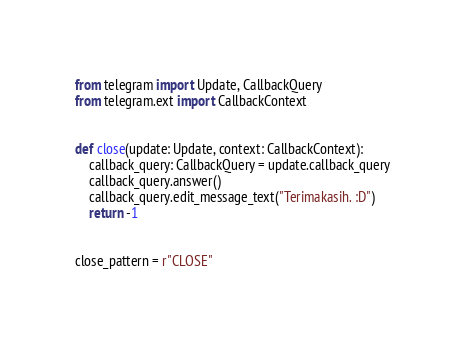<code> <loc_0><loc_0><loc_500><loc_500><_Python_>from telegram import Update, CallbackQuery
from telegram.ext import CallbackContext


def close(update: Update, context: CallbackContext):
    callback_query: CallbackQuery = update.callback_query
    callback_query.answer()
    callback_query.edit_message_text("Terimakasih. :D")
    return -1


close_pattern = r"CLOSE"
</code> 